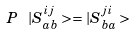Convert formula to latex. <formula><loc_0><loc_0><loc_500><loc_500>P \ | S _ { a b } ^ { i j } > = | S _ { b a } ^ { j i } ></formula> 